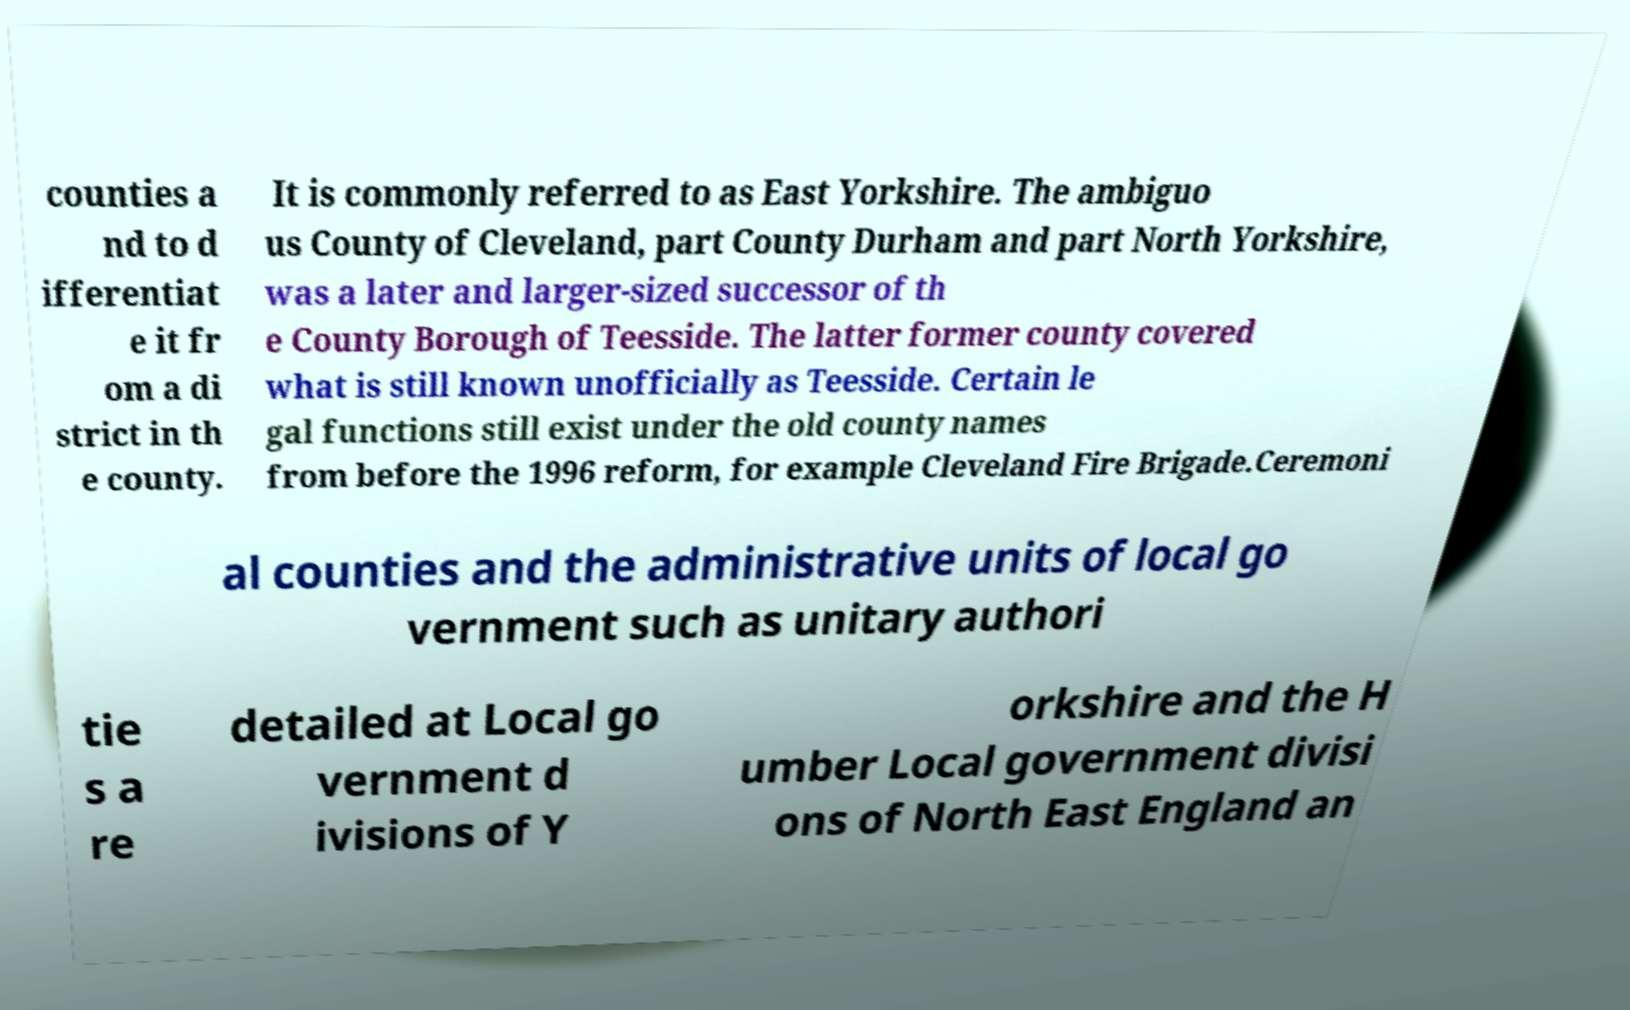Please read and relay the text visible in this image. What does it say? counties a nd to d ifferentiat e it fr om a di strict in th e county. It is commonly referred to as East Yorkshire. The ambiguo us County of Cleveland, part County Durham and part North Yorkshire, was a later and larger-sized successor of th e County Borough of Teesside. The latter former county covered what is still known unofficially as Teesside. Certain le gal functions still exist under the old county names from before the 1996 reform, for example Cleveland Fire Brigade.Ceremoni al counties and the administrative units of local go vernment such as unitary authori tie s a re detailed at Local go vernment d ivisions of Y orkshire and the H umber Local government divisi ons of North East England an 